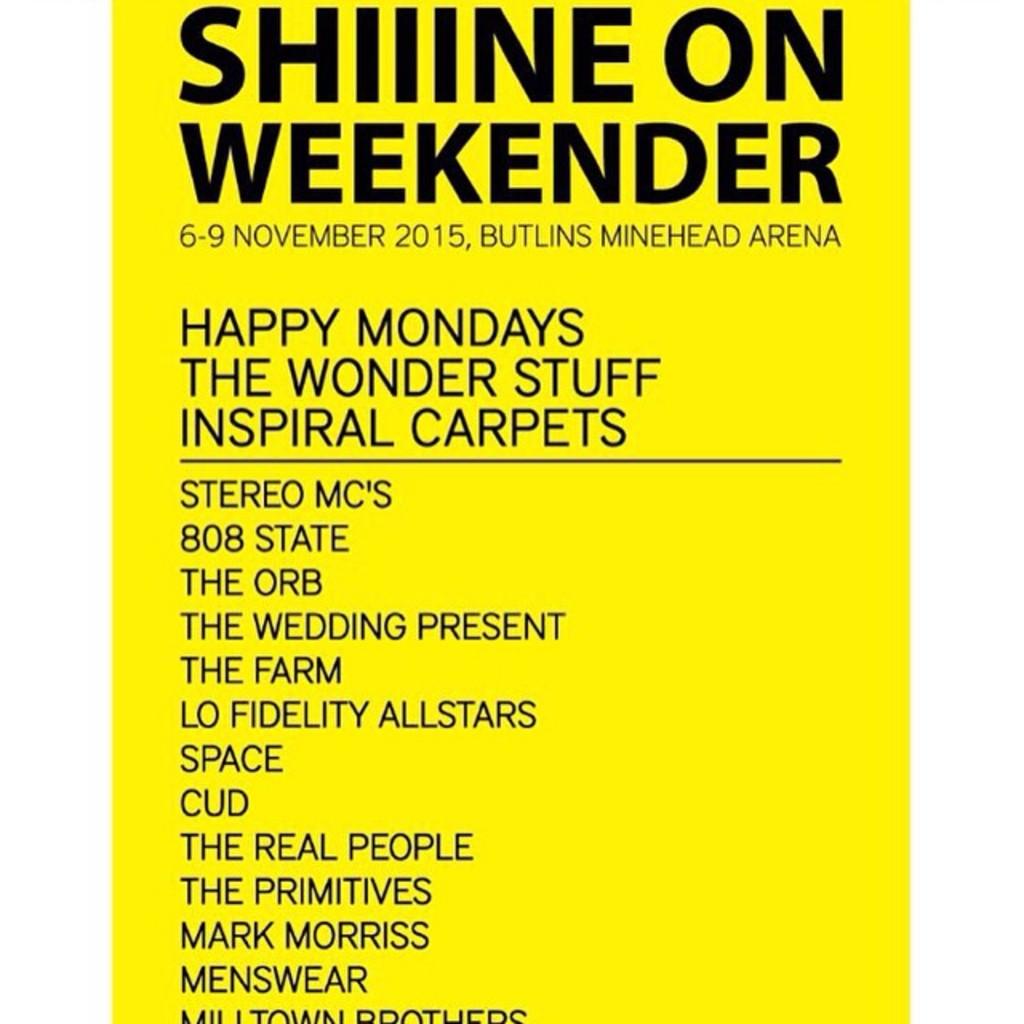What year does this event occur?
Ensure brevity in your answer.  2015. What band has top billing?
Keep it short and to the point. Stereo mc's. 